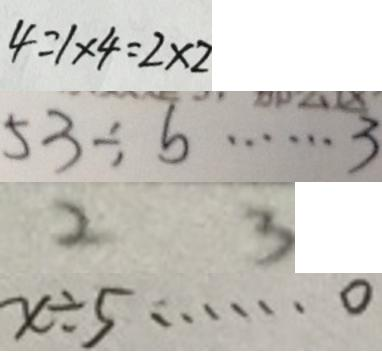<formula> <loc_0><loc_0><loc_500><loc_500>4 = 1 \times 4 = 2 \times 2 
 5 3 \div b \cdots 3 
 2 3 
 x \div 5 \cdots 0</formula> 